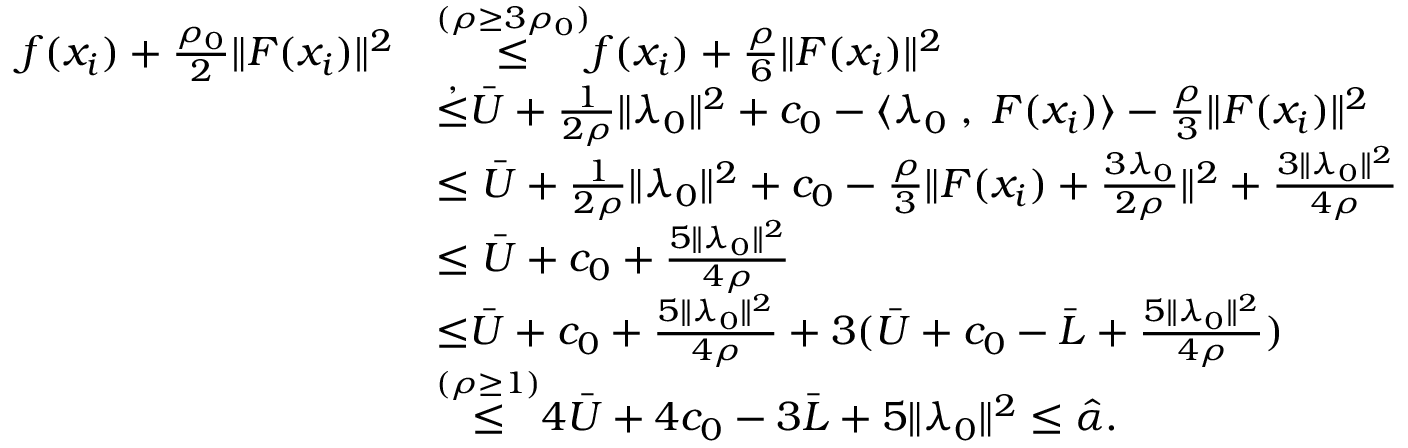<formula> <loc_0><loc_0><loc_500><loc_500>\begin{array} { r l } { f ( x _ { i } ) + \frac { \rho _ { 0 } } { 2 } \| F ( x _ { i } ) \| ^ { 2 } } & { { \overset { { ( \rho \geq 3 \rho _ { 0 } ) } } { \leq } } f ( x _ { i } ) + \frac { \rho } { 6 } \| F ( x _ { i } ) \| ^ { 2 } } \\ & { { \overset { , } { \leq } } \bar { U } + \frac { 1 } { 2 \rho } \| \lambda _ { 0 } \| ^ { 2 } + c _ { 0 } - \langle \lambda _ { 0 } \, , \, F ( x _ { i } ) \rangle - \frac { \rho } { 3 } \| F ( x _ { i } ) \| ^ { 2 } } \\ & { \leq \bar { U } + \frac { 1 } { 2 \rho } \| \lambda _ { 0 } \| ^ { 2 } + c _ { 0 } - \frac { \rho } { 3 } \| F ( x _ { i } ) + \frac { 3 \lambda _ { 0 } } { 2 \rho } \| ^ { 2 } + \frac { 3 \| \lambda _ { 0 } \| ^ { 2 } } { 4 \rho } } \\ & { \leq \bar { U } + c _ { 0 } + \frac { 5 \| \lambda _ { 0 } \| ^ { 2 } } { 4 \rho } } \\ & { { { \leq } } \bar { U } + c _ { 0 } + \frac { 5 \| \lambda _ { 0 } \| ^ { 2 } } { 4 \rho } + 3 ( \bar { U } + c _ { 0 } - \bar { L } + \frac { 5 \| \lambda _ { 0 } \| ^ { 2 } } { 4 \rho } ) } \\ & { { \overset { ( \rho \geq 1 ) } { \leq } } 4 \bar { U } + 4 c _ { 0 } - 3 \bar { L } + { 5 \| \lambda _ { 0 } \| ^ { 2 } } \leq \hat { \alpha } . } \end{array}</formula> 